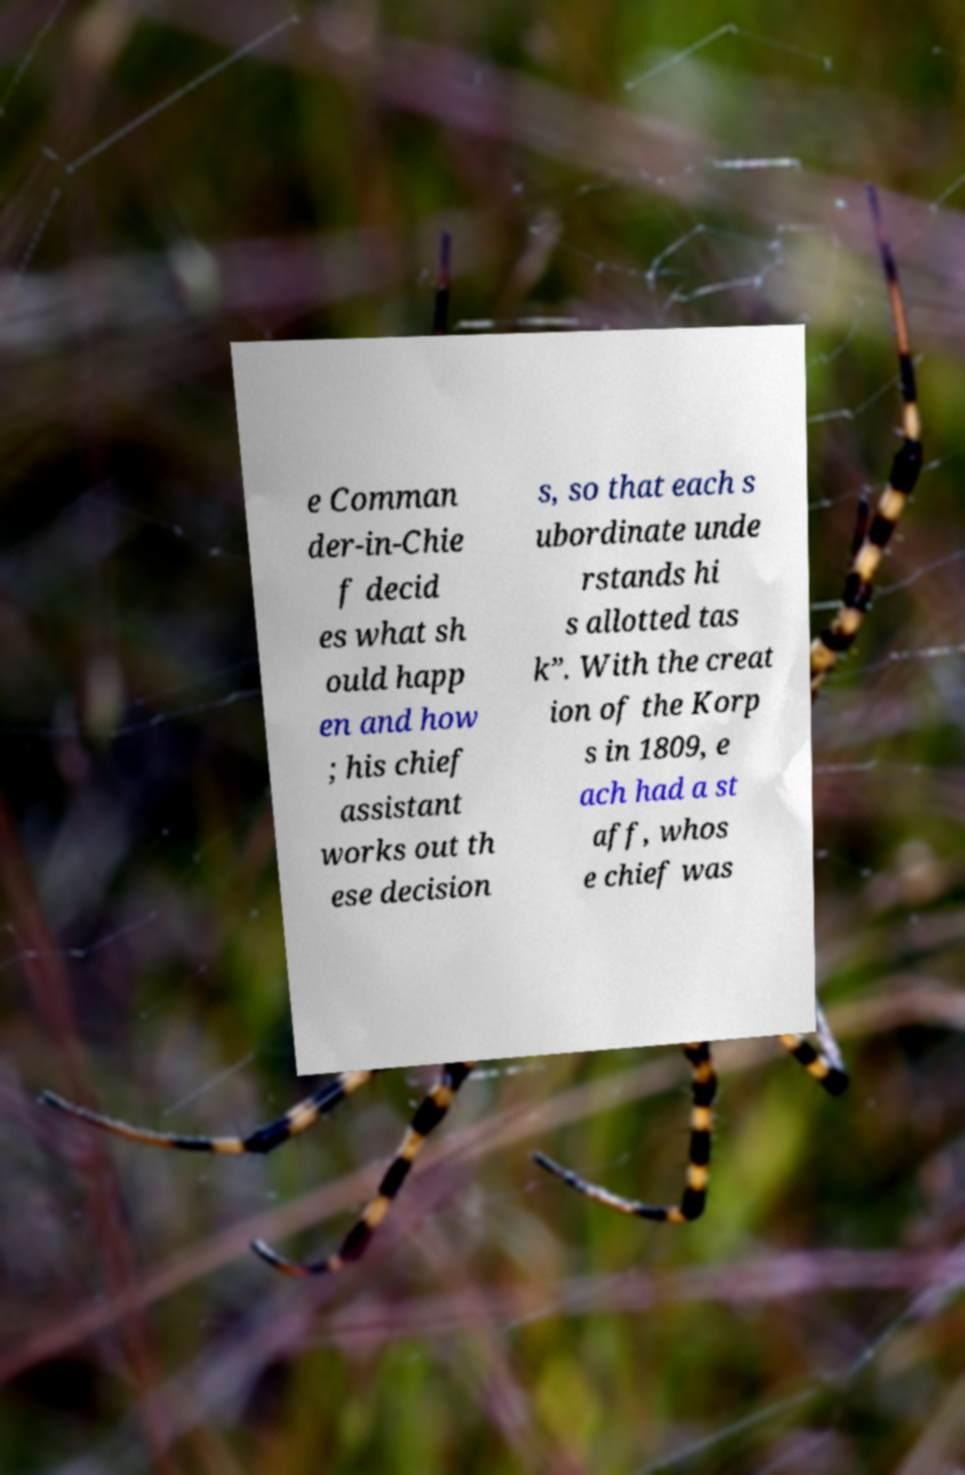Can you accurately transcribe the text from the provided image for me? e Comman der-in-Chie f decid es what sh ould happ en and how ; his chief assistant works out th ese decision s, so that each s ubordinate unde rstands hi s allotted tas k”. With the creat ion of the Korp s in 1809, e ach had a st aff, whos e chief was 